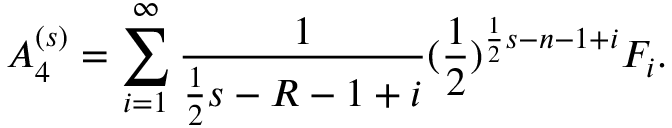<formula> <loc_0><loc_0><loc_500><loc_500>A _ { 4 } ^ { ( s ) } = \sum _ { i = 1 } ^ { \infty } \frac { 1 } { \frac { 1 } { 2 } s - R - 1 + i } ( \frac { 1 } { 2 } ) ^ { \frac { 1 } { 2 } s - n - 1 + i } F _ { i } .</formula> 